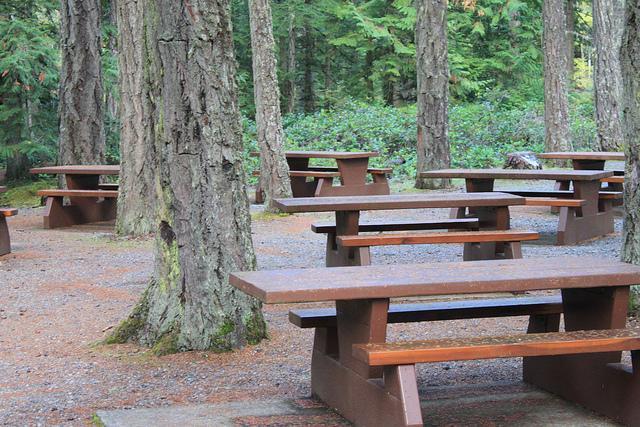How many tables are empty?
Give a very brief answer. 6. How many benches are there?
Give a very brief answer. 5. How many people are standing by the fence?
Give a very brief answer. 0. 